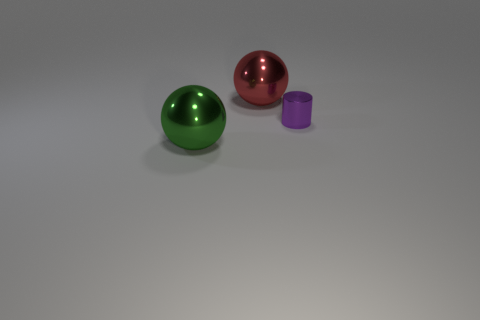Is there any other thing that is the same shape as the small thing?
Your answer should be very brief. No. Is the shape of the large metal object on the right side of the big green shiny thing the same as  the large green shiny thing?
Provide a short and direct response. Yes. There is a ball left of the large shiny ball right of the green object; how big is it?
Offer a terse response. Large. The other small thing that is made of the same material as the red thing is what color?
Offer a very short reply. Purple. How many objects are the same size as the shiny cylinder?
Your answer should be very brief. 0. What number of cyan objects are tiny metallic things or metallic spheres?
Provide a succinct answer. 0. How many objects are either purple things or shiny objects that are on the left side of the shiny cylinder?
Ensure brevity in your answer.  3. What material is the big thing that is on the right side of the green metal object?
Your answer should be compact. Metal. There is another shiny object that is the same size as the red shiny thing; what is its shape?
Provide a succinct answer. Sphere. Is there another large shiny object of the same shape as the big red shiny thing?
Your response must be concise. Yes. 